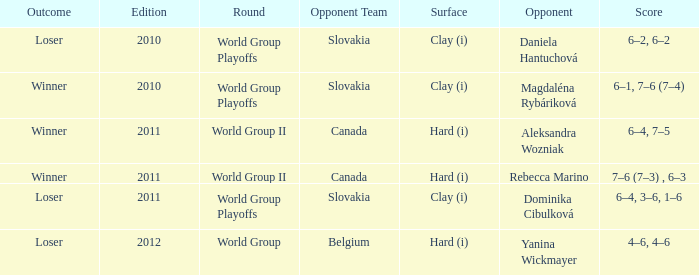What was the result of the game when the adversary was magdaléna rybáriková? Winner. 